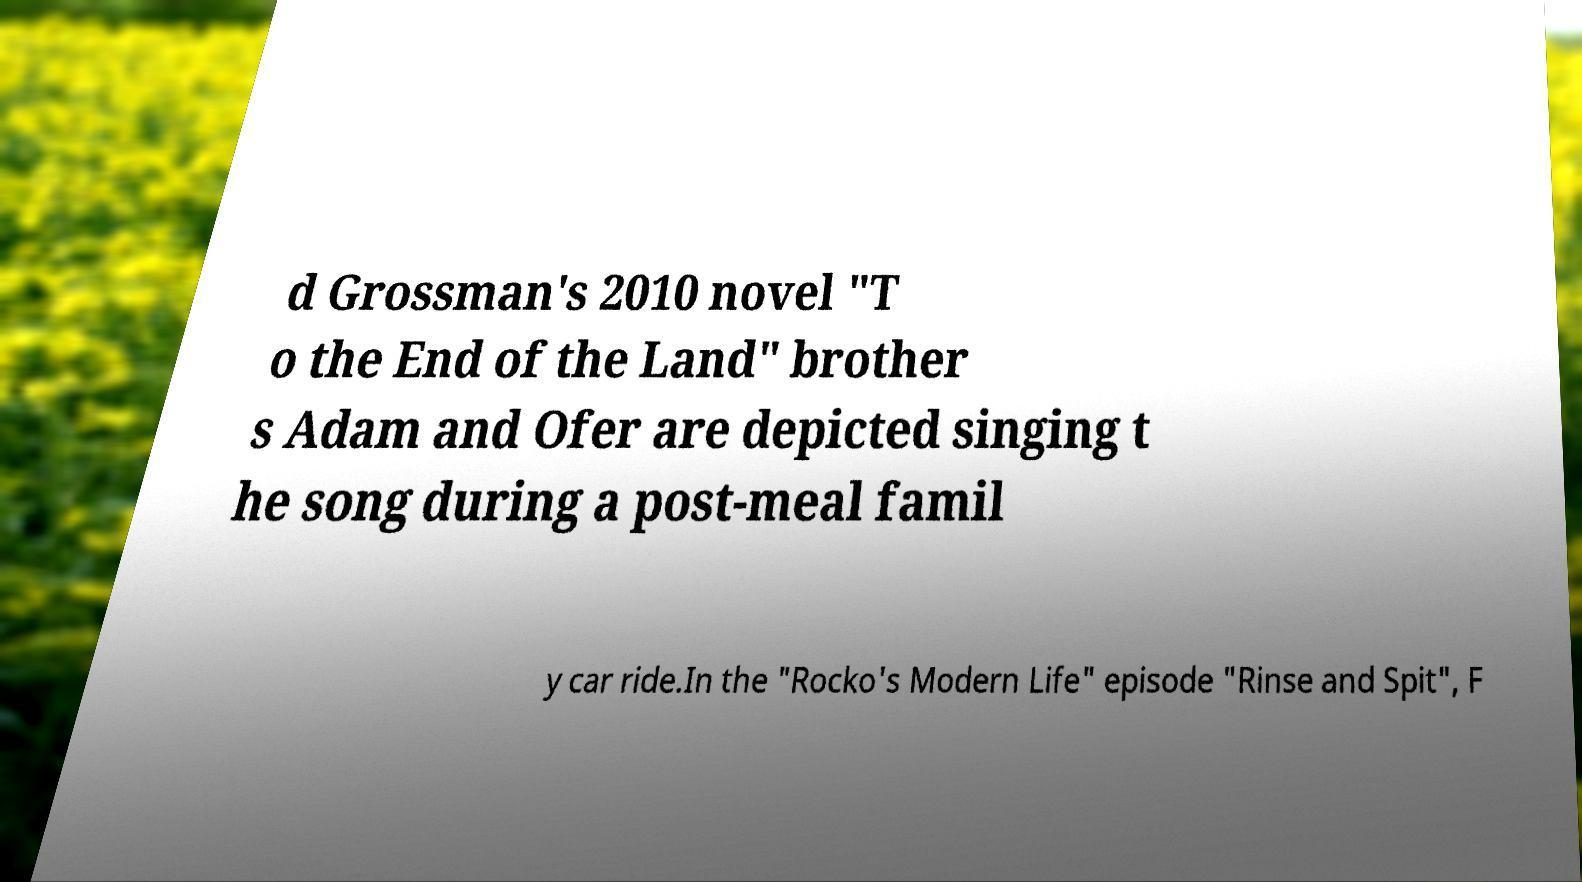Could you extract and type out the text from this image? d Grossman's 2010 novel "T o the End of the Land" brother s Adam and Ofer are depicted singing t he song during a post-meal famil y car ride.In the "Rocko's Modern Life" episode "Rinse and Spit", F 